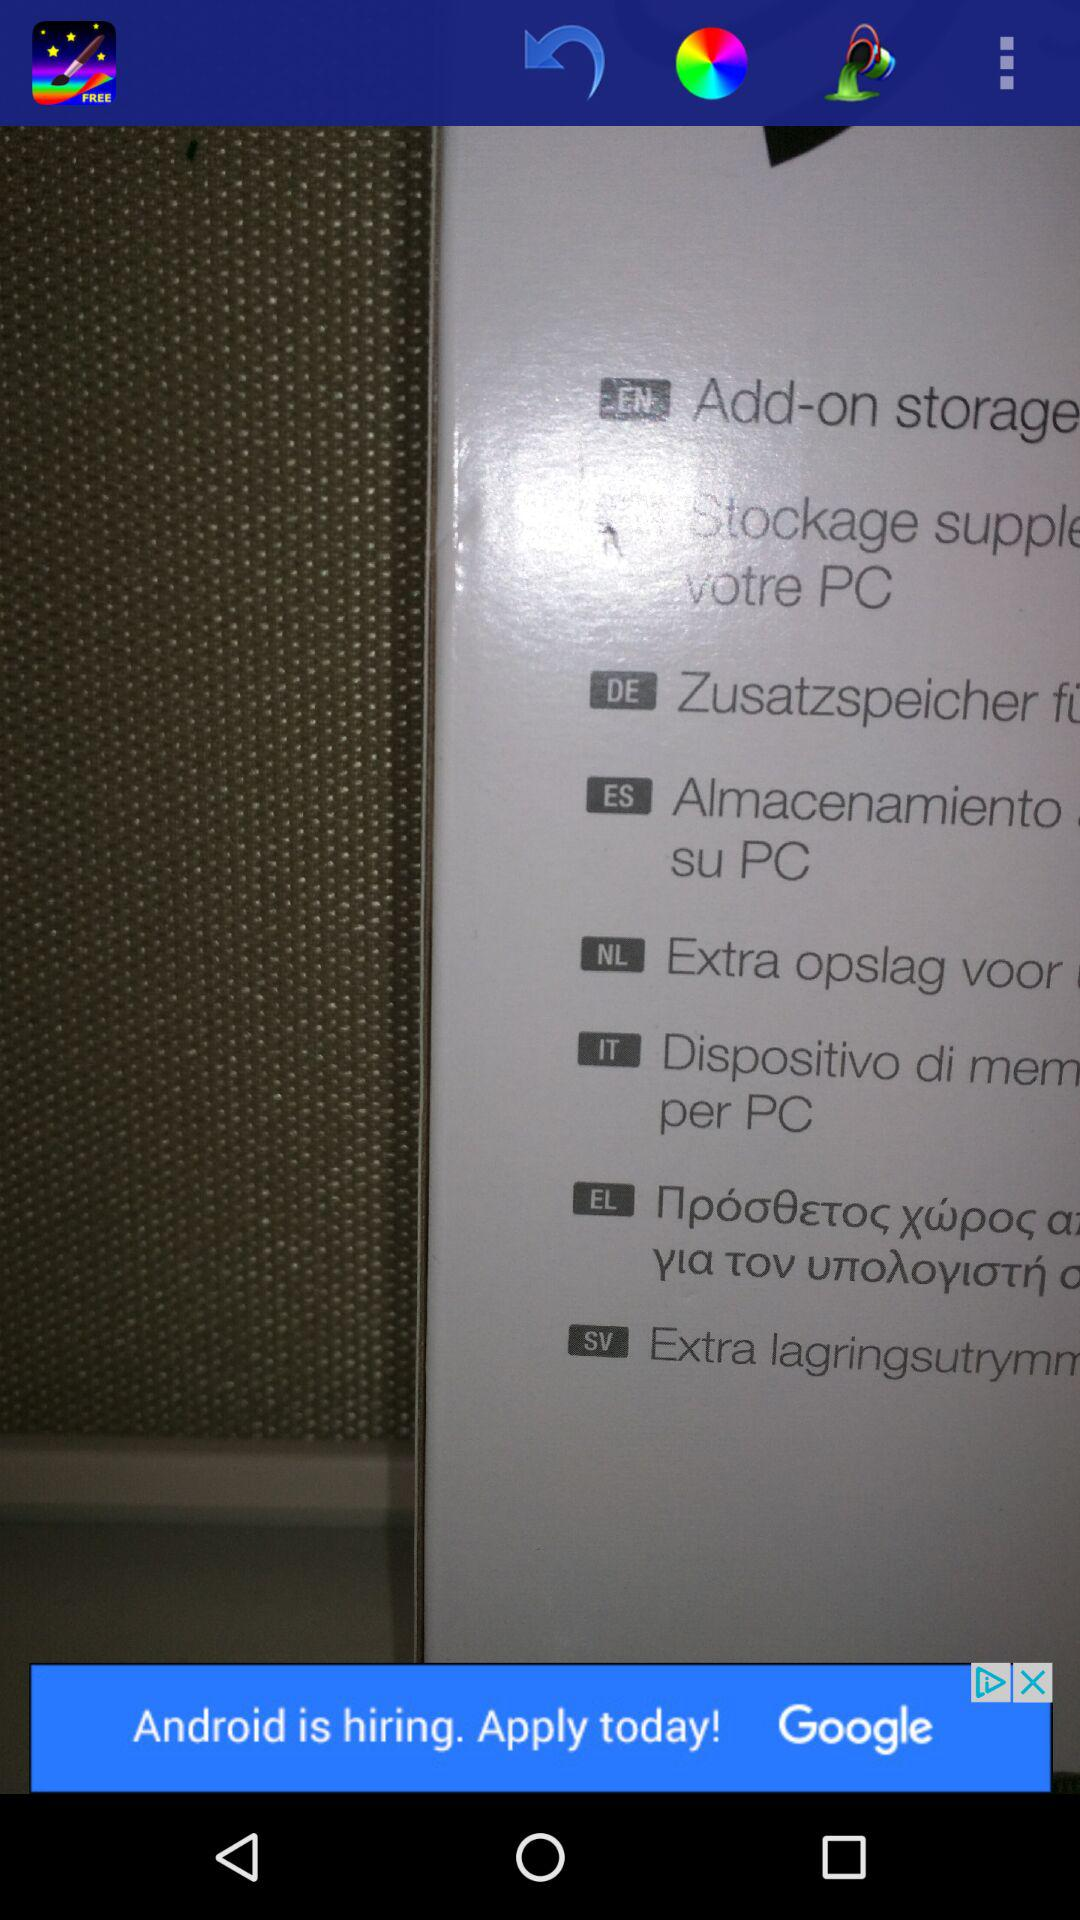How many different languages are available on the app?
Answer the question using a single word or phrase. 8 